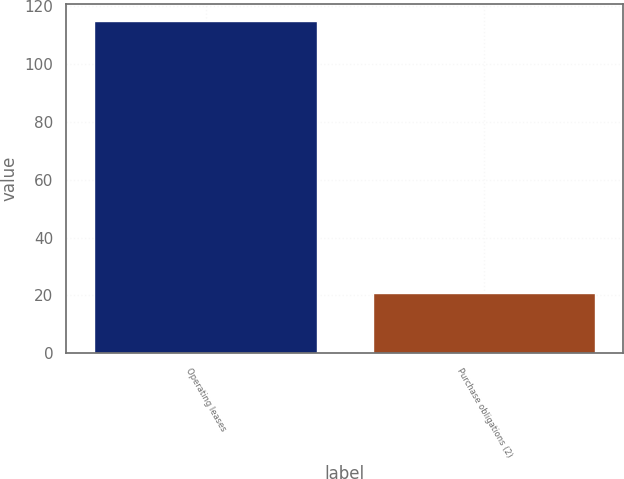Convert chart. <chart><loc_0><loc_0><loc_500><loc_500><bar_chart><fcel>Operating leases<fcel>Purchase obligations (2)<nl><fcel>115<fcel>21<nl></chart> 